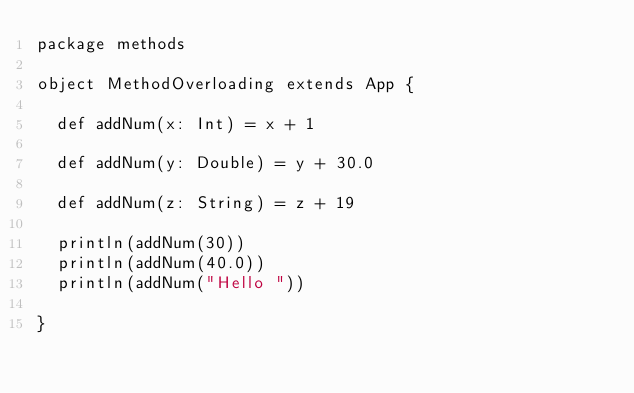Convert code to text. <code><loc_0><loc_0><loc_500><loc_500><_Scala_>package methods

object MethodOverloading extends App {

  def addNum(x: Int) = x + 1

  def addNum(y: Double) = y + 30.0

  def addNum(z: String) = z + 19

  println(addNum(30))
  println(addNum(40.0))
  println(addNum("Hello "))

}
</code> 